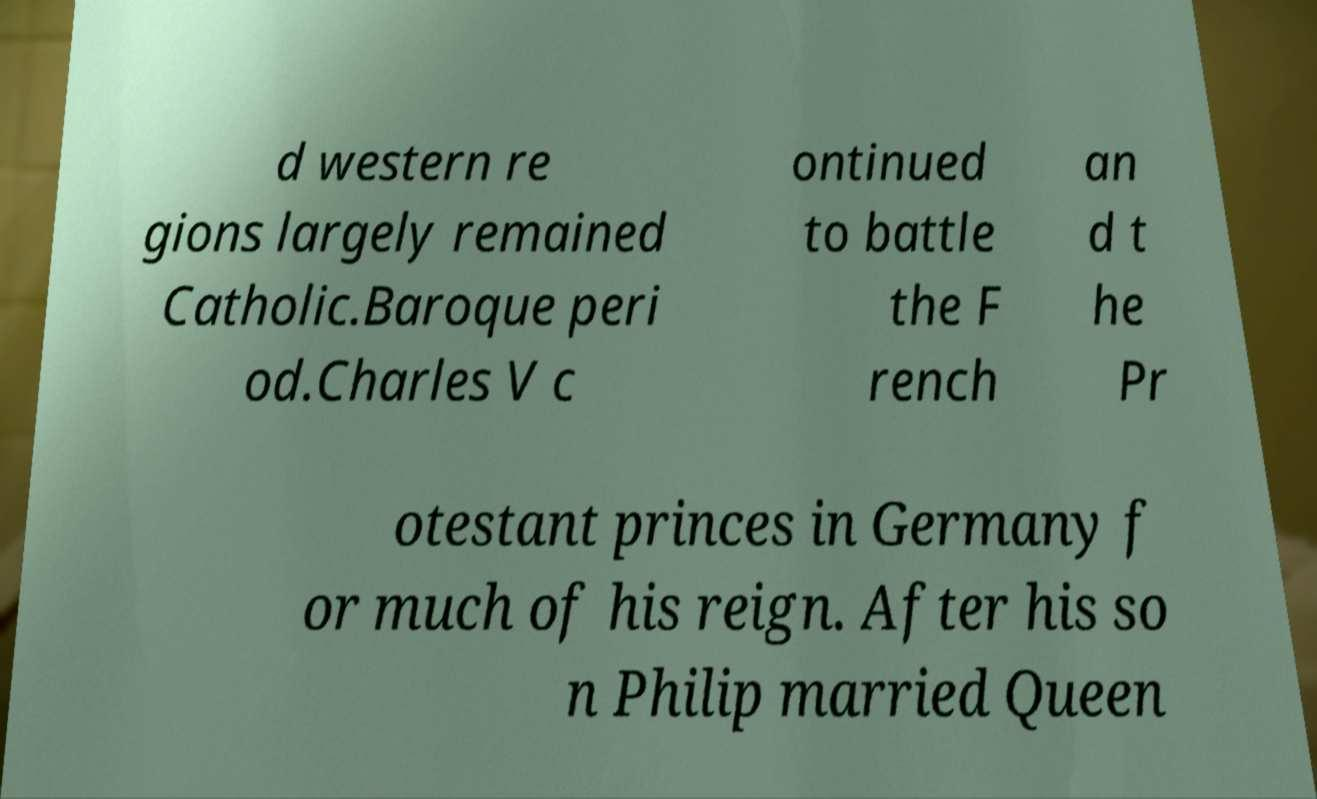For documentation purposes, I need the text within this image transcribed. Could you provide that? d western re gions largely remained Catholic.Baroque peri od.Charles V c ontinued to battle the F rench an d t he Pr otestant princes in Germany f or much of his reign. After his so n Philip married Queen 